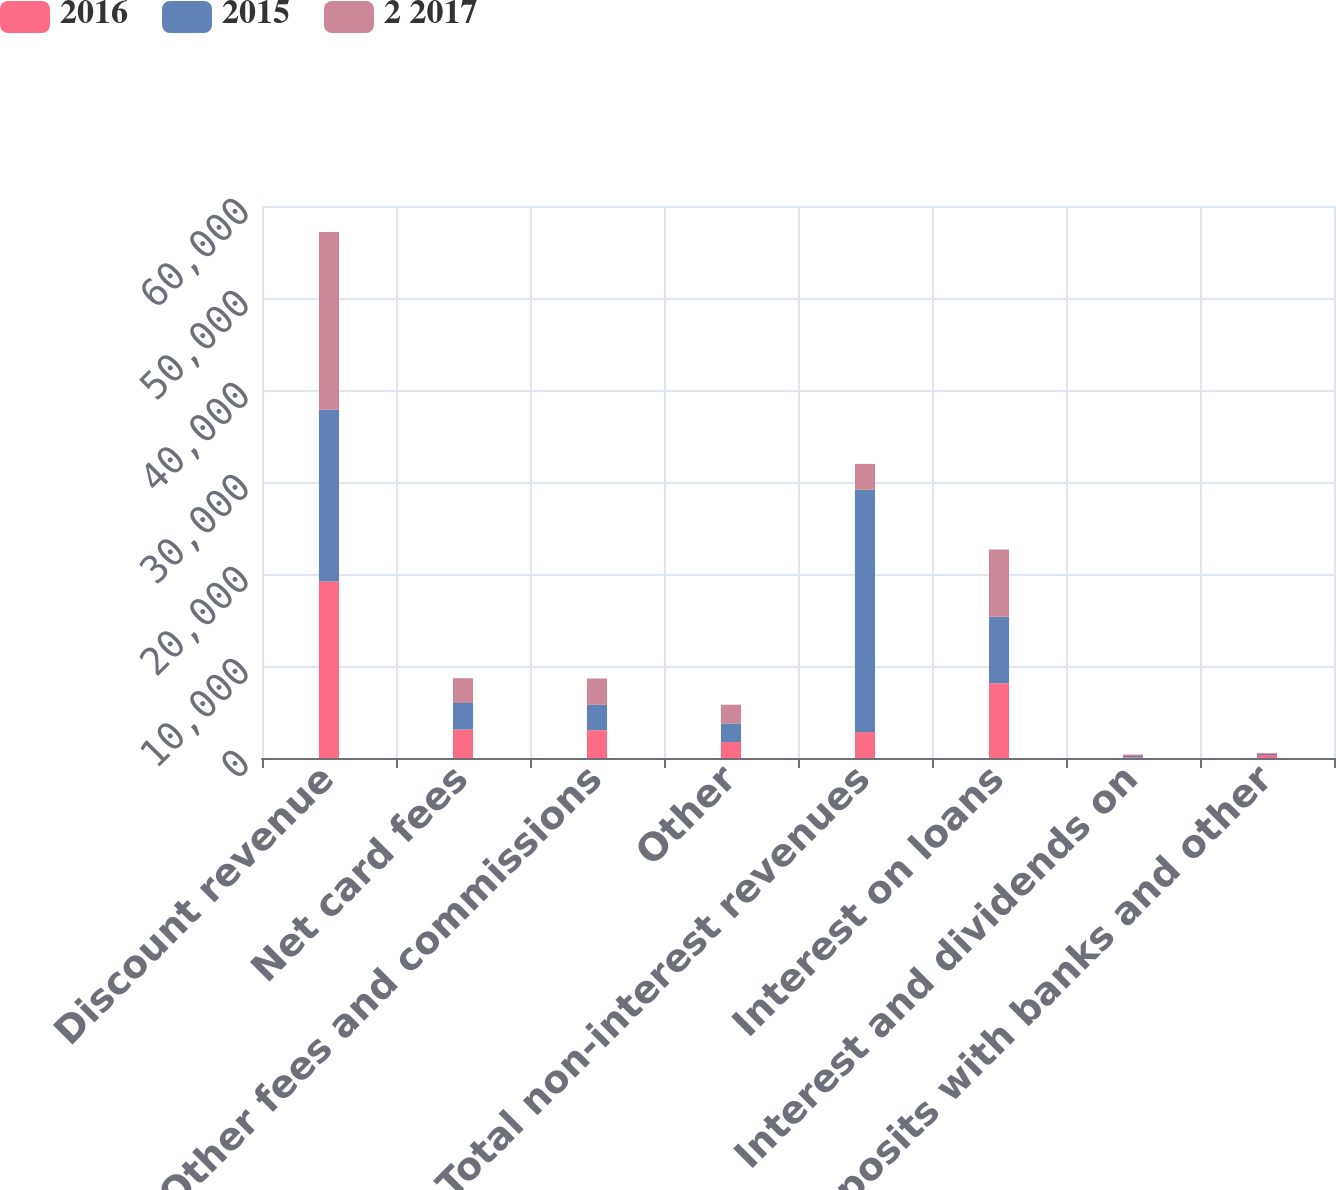Convert chart. <chart><loc_0><loc_0><loc_500><loc_500><stacked_bar_chart><ecel><fcel>Discount revenue<fcel>Net card fees<fcel>Other fees and commissions<fcel>Other<fcel>Total non-interest revenues<fcel>Interest on loans<fcel>Interest and dividends on<fcel>Deposits with banks and other<nl><fcel>2016<fcel>19186<fcel>3090<fcel>3022<fcel>1732<fcel>2809.5<fcel>8138<fcel>89<fcel>326<nl><fcel>2015<fcel>18680<fcel>2886<fcel>2753<fcel>2029<fcel>26348<fcel>7205<fcel>131<fcel>139<nl><fcel>2 2017<fcel>19297<fcel>2700<fcel>2866<fcel>2033<fcel>2809.5<fcel>7309<fcel>157<fcel>79<nl></chart> 